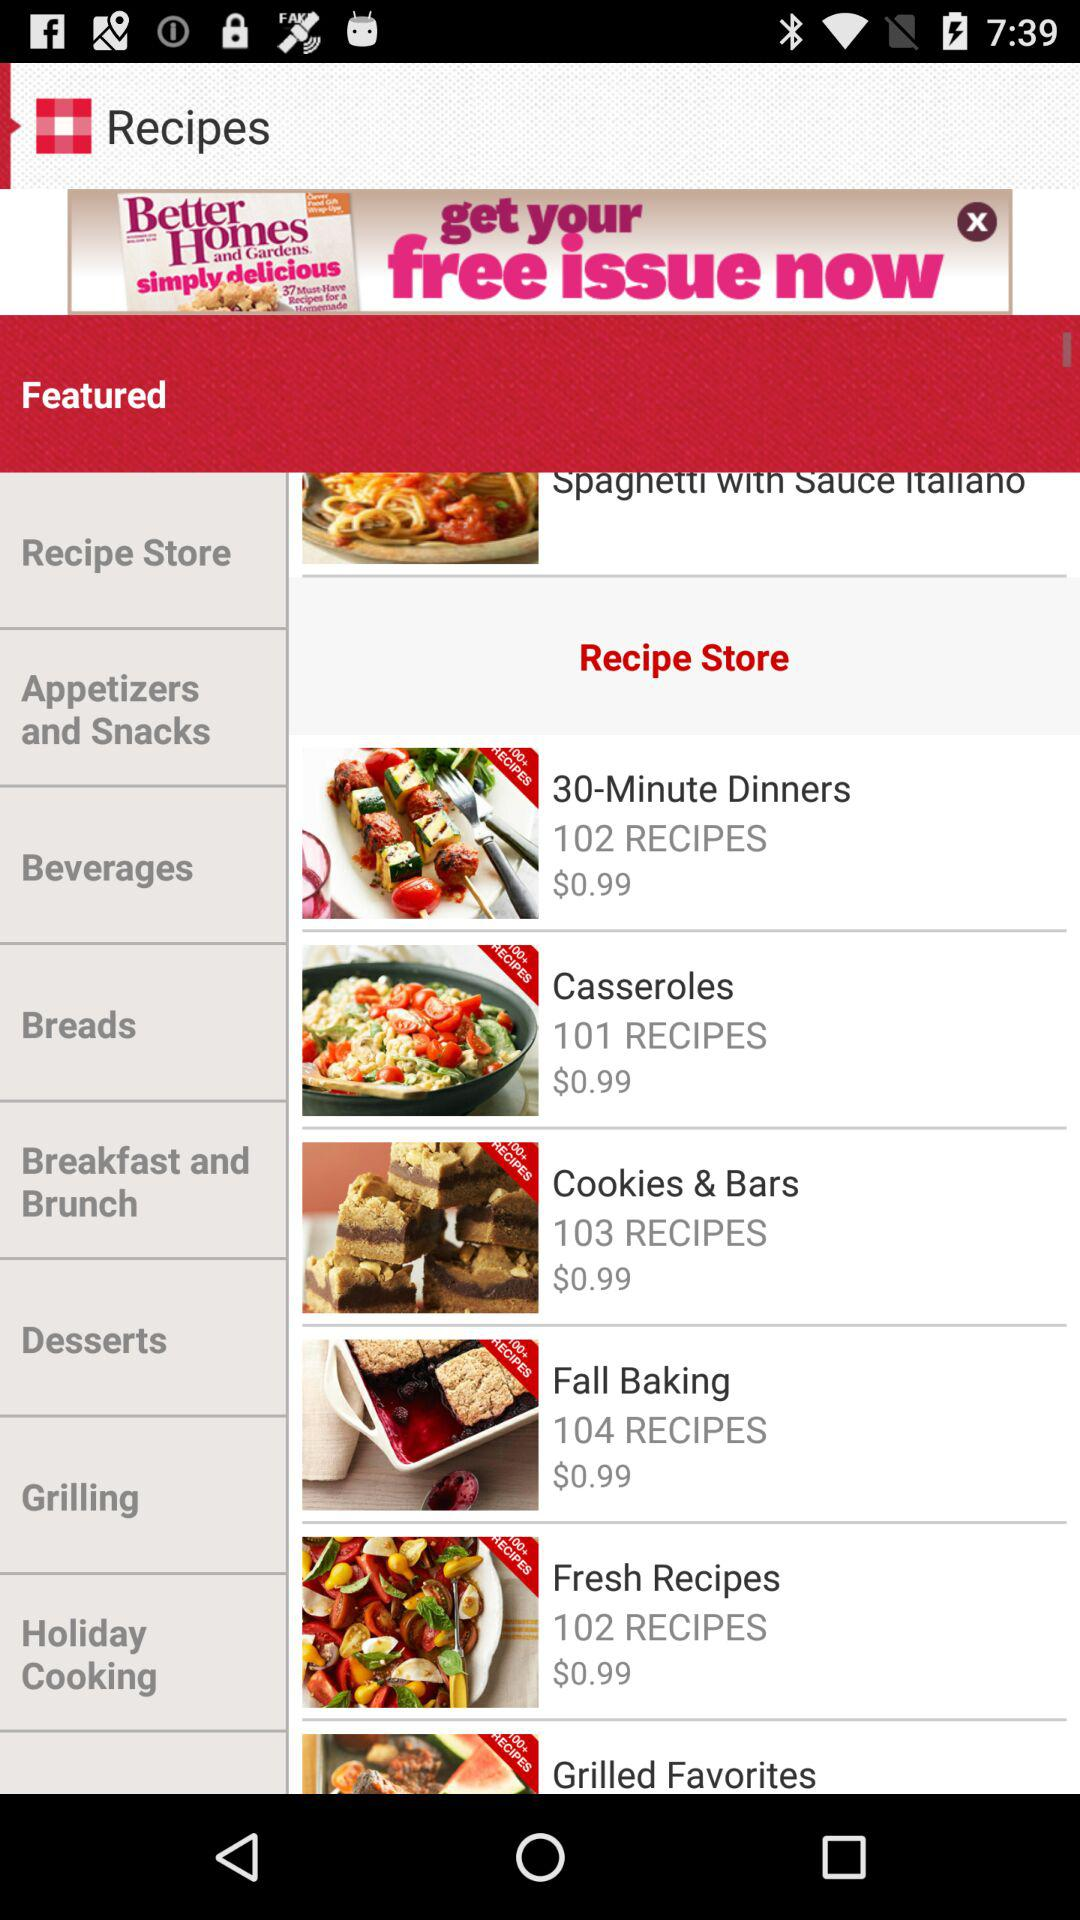What is the number of recipes in "Cookies & Bars"? The number of recipes in "Cookies & Bars" is 103. 